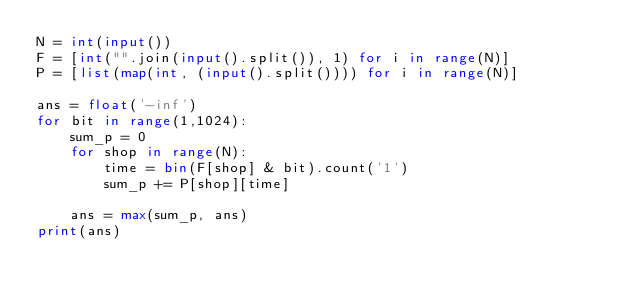<code> <loc_0><loc_0><loc_500><loc_500><_Python_>N = int(input())
F = [int("".join(input().split()), 1) for i in range(N)]
P = [list(map(int, (input().split()))) for i in range(N)]

ans = float('-inf')
for bit in range(1,1024):
    sum_p = 0
    for shop in range(N):
        time = bin(F[shop] & bit).count('1')
        sum_p += P[shop][time]

    ans = max(sum_p, ans)
print(ans)
</code> 